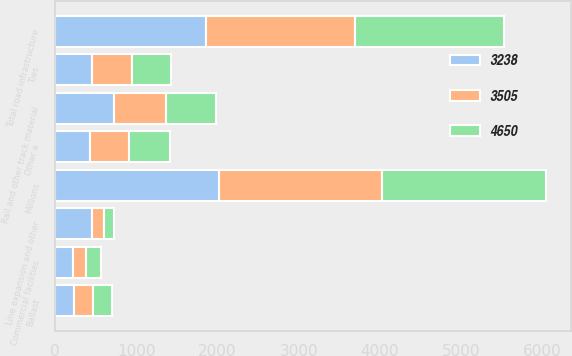Convert chart. <chart><loc_0><loc_0><loc_500><loc_500><stacked_bar_chart><ecel><fcel>Millions<fcel>Rail and other track material<fcel>Ties<fcel>Ballast<fcel>Other a<fcel>Total road infrastructure<fcel>Line expansion and other<fcel>Commercial facilities<nl><fcel>4650<fcel>2017<fcel>619<fcel>480<fcel>231<fcel>503<fcel>1833<fcel>124<fcel>189<nl><fcel>3505<fcel>2016<fcel>628<fcel>494<fcel>235<fcel>480<fcel>1837<fcel>153<fcel>152<nl><fcel>3238<fcel>2015<fcel>734<fcel>455<fcel>233<fcel>438<fcel>1860<fcel>457<fcel>227<nl></chart> 